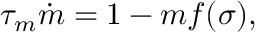<formula> <loc_0><loc_0><loc_500><loc_500>\tau _ { m } \dot { m } = 1 - m f ( \sigma ) ,</formula> 